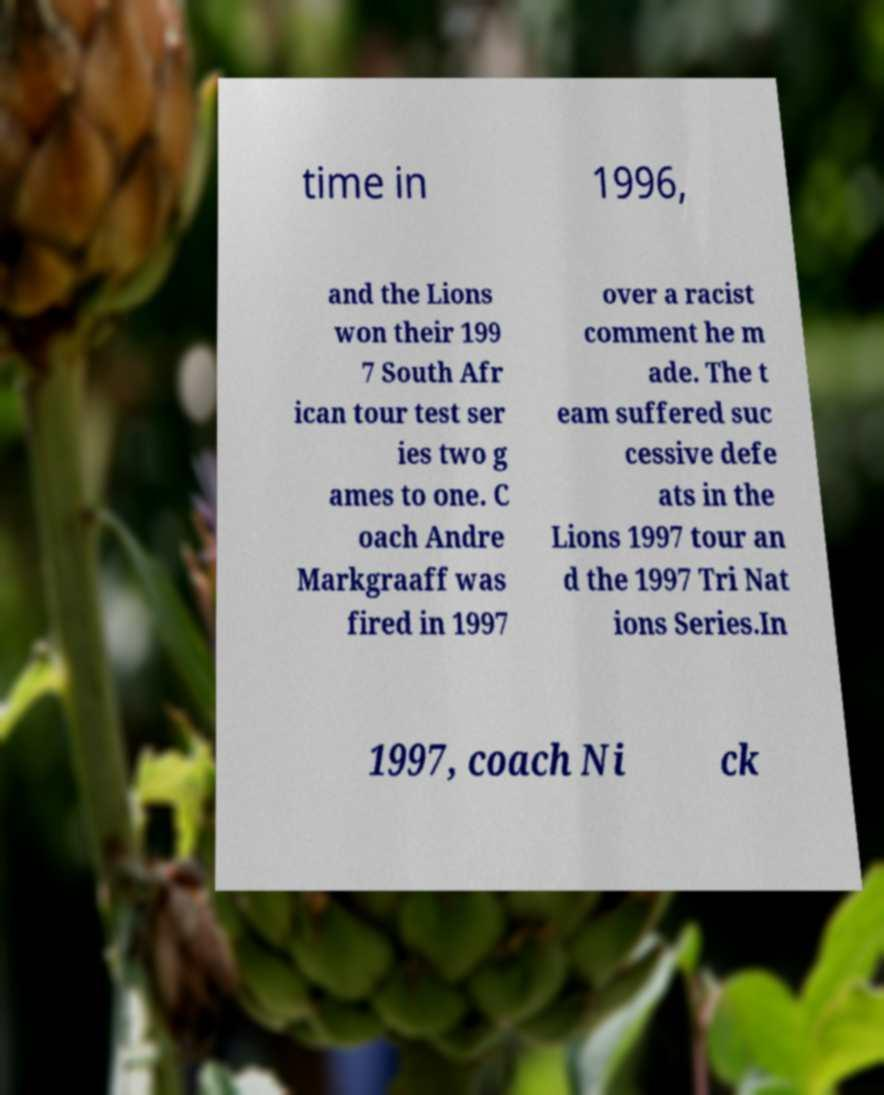Can you read and provide the text displayed in the image?This photo seems to have some interesting text. Can you extract and type it out for me? time in 1996, and the Lions won their 199 7 South Afr ican tour test ser ies two g ames to one. C oach Andre Markgraaff was fired in 1997 over a racist comment he m ade. The t eam suffered suc cessive defe ats in the Lions 1997 tour an d the 1997 Tri Nat ions Series.In 1997, coach Ni ck 